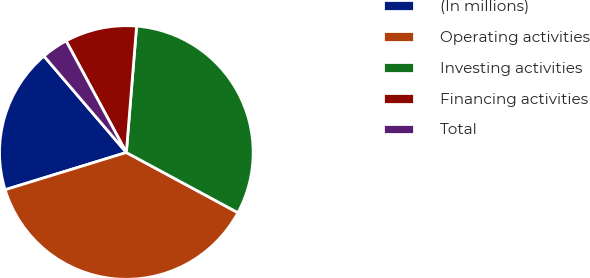<chart> <loc_0><loc_0><loc_500><loc_500><pie_chart><fcel>(In millions)<fcel>Operating activities<fcel>Investing activities<fcel>Financing activities<fcel>Total<nl><fcel>18.49%<fcel>37.38%<fcel>31.58%<fcel>9.17%<fcel>3.37%<nl></chart> 